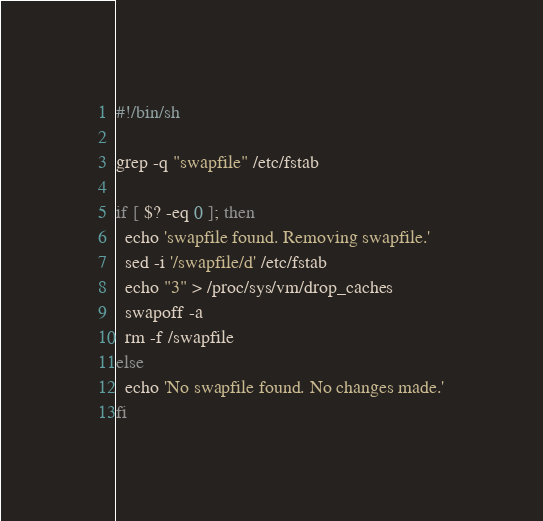Convert code to text. <code><loc_0><loc_0><loc_500><loc_500><_Bash_>#!/bin/sh

grep -q "swapfile" /etc/fstab

if [ $? -eq 0 ]; then
  echo 'swapfile found. Removing swapfile.'
  sed -i '/swapfile/d' /etc/fstab
  echo "3" > /proc/sys/vm/drop_caches
  swapoff -a
  rm -f /swapfile
else
  echo 'No swapfile found. No changes made.'
fi
</code> 